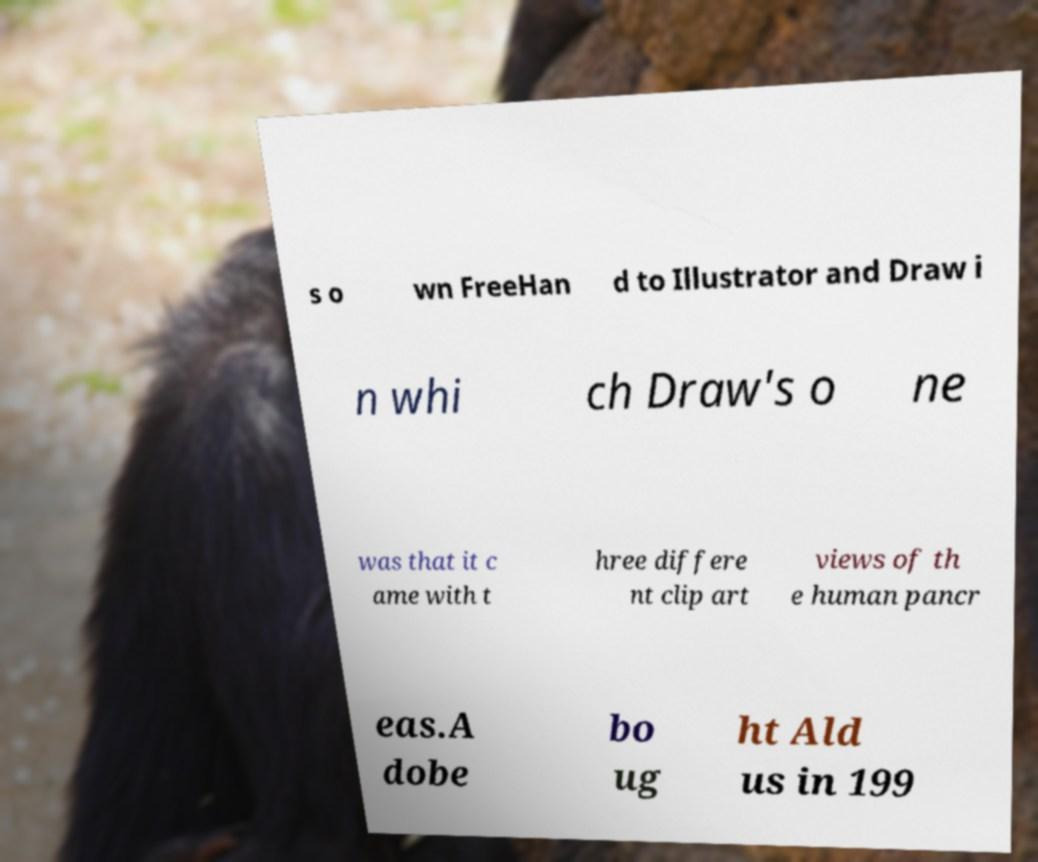Could you extract and type out the text from this image? s o wn FreeHan d to Illustrator and Draw i n whi ch Draw's o ne was that it c ame with t hree differe nt clip art views of th e human pancr eas.A dobe bo ug ht Ald us in 199 